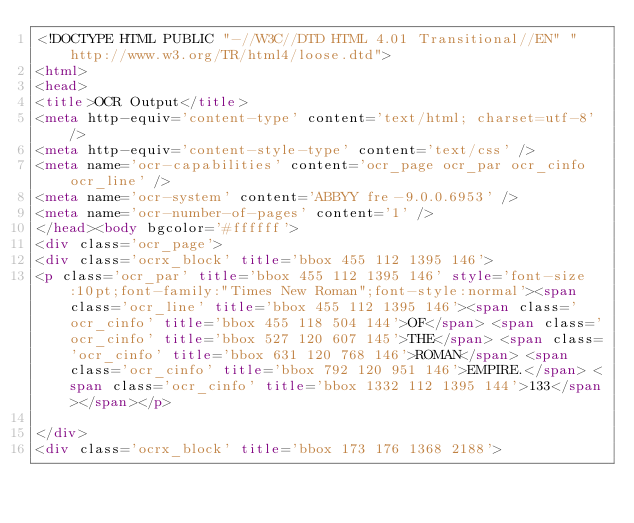<code> <loc_0><loc_0><loc_500><loc_500><_HTML_><!DOCTYPE HTML PUBLIC "-//W3C//DTD HTML 4.01 Transitional//EN" "http://www.w3.org/TR/html4/loose.dtd">
<html>
<head>
<title>OCR Output</title>
<meta http-equiv='content-type' content='text/html; charset=utf-8' />
<meta http-equiv='content-style-type' content='text/css' />
<meta name='ocr-capabilities' content='ocr_page ocr_par ocr_cinfo ocr_line' />
<meta name='ocr-system' content='ABBYY fre-9.0.0.6953' />
<meta name='ocr-number-of-pages' content='1' />
</head><body bgcolor='#ffffff'>
<div class='ocr_page'>
<div class='ocrx_block' title='bbox 455 112 1395 146'>
<p class='ocr_par' title='bbox 455 112 1395 146' style='font-size:10pt;font-family:"Times New Roman";font-style:normal'><span class='ocr_line' title='bbox 455 112 1395 146'><span class='ocr_cinfo' title='bbox 455 118 504 144'>OF</span> <span class='ocr_cinfo' title='bbox 527 120 607 145'>THE</span> <span class='ocr_cinfo' title='bbox 631 120 768 146'>ROMAN</span> <span class='ocr_cinfo' title='bbox 792 120 951 146'>EMPIRE.</span> <span class='ocr_cinfo' title='bbox 1332 112 1395 144'>133</span></span></p>

</div>
<div class='ocrx_block' title='bbox 173 176 1368 2188'></code> 